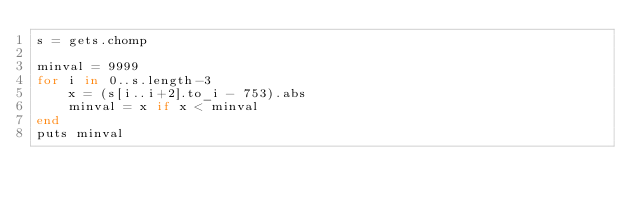Convert code to text. <code><loc_0><loc_0><loc_500><loc_500><_Ruby_>s = gets.chomp

minval = 9999
for i in 0..s.length-3
    x = (s[i..i+2].to_i - 753).abs
    minval = x if x < minval
end
puts minval
</code> 